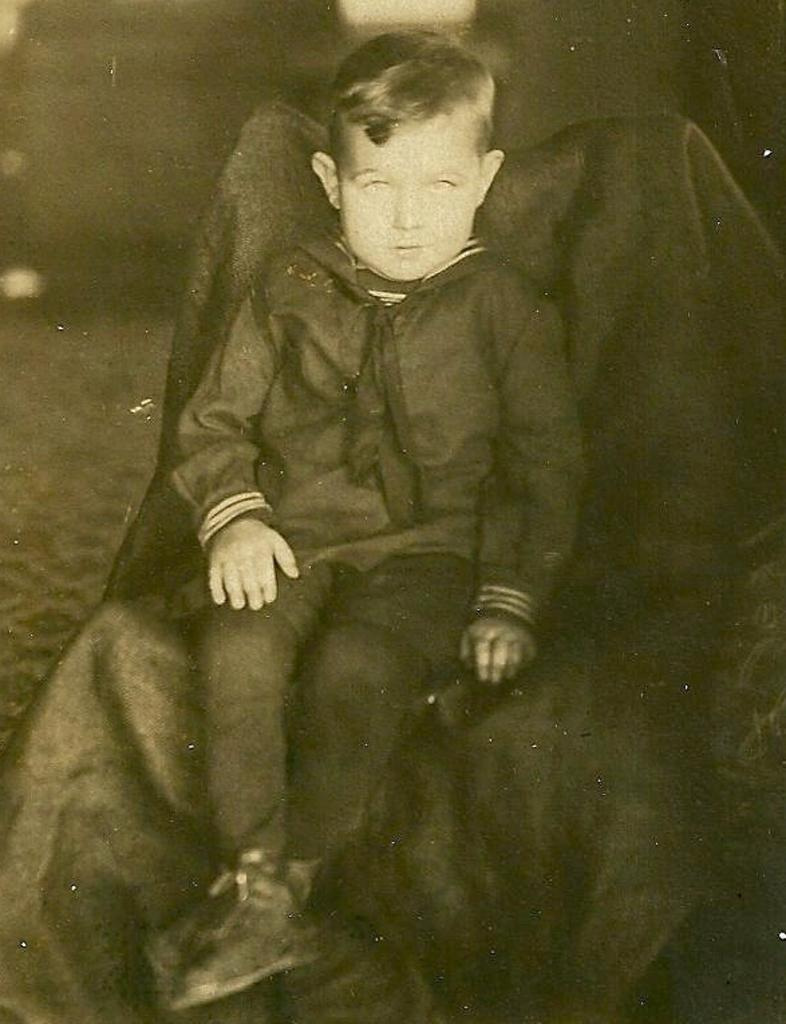What is the color scheme of the image? The image is in black and white. Who is present in the image? There is a boy in the image. What is the boy doing in the image? The boy is sitting on a chair. What is covering the chair? The chair is covered with a cloth. How many trees can be seen in the image? There are no trees visible in the image; it is a black and white image of a boy sitting on a chair with a cloth-covered chair. What type of zinc is present in the image? There is no zinc present in the image. 